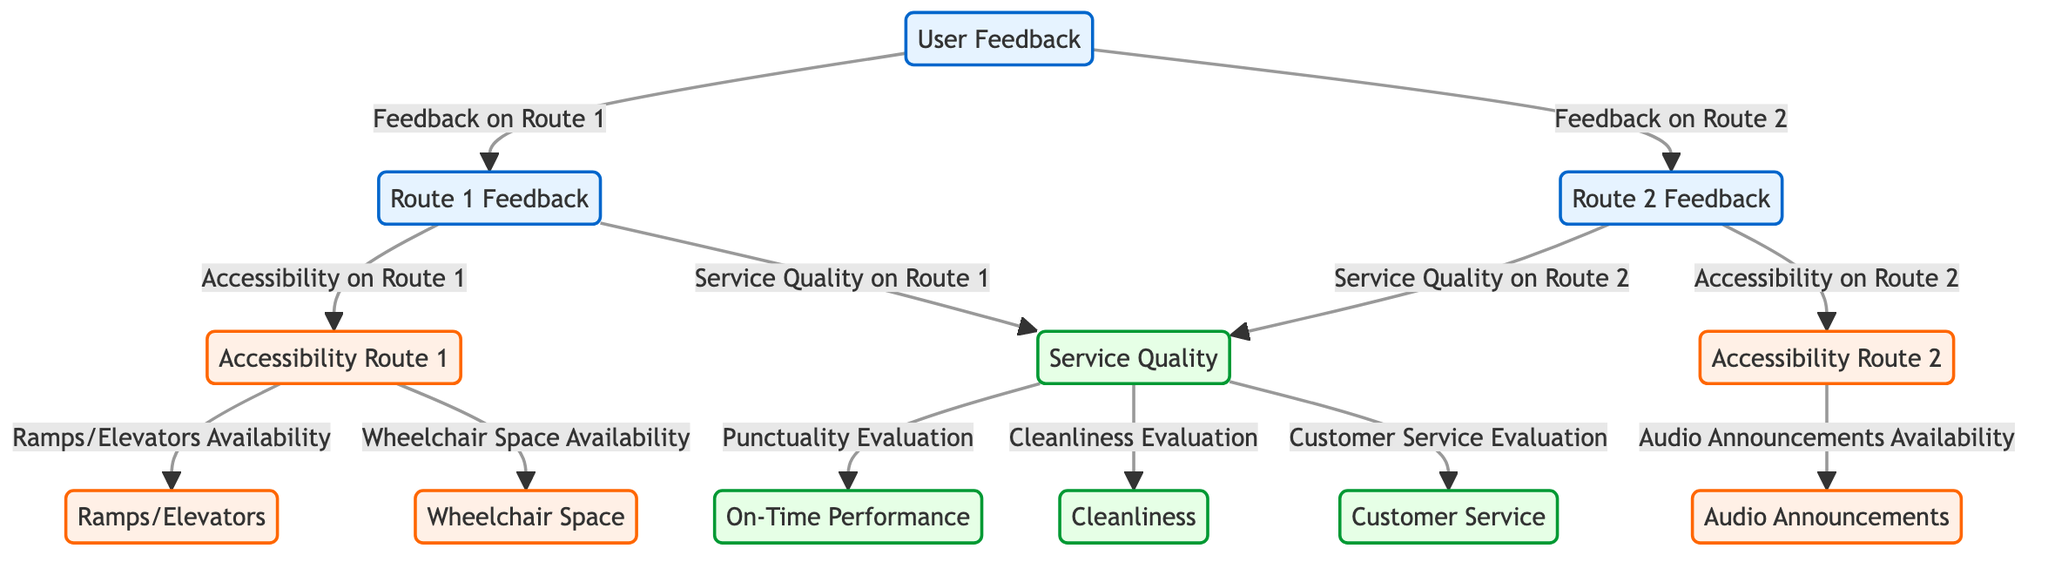What are the two routes represented in the user feedback? The diagram shows feedback specifically for Route 1 and Route 2, which can be identified at the top nodes branching from the User Feedback node.
Answer: Route 1, Route 2 How many types of accessibility features are linked to Route 1? The diagram indicates that Route 1 has two specific accessibility features: Ramps/Elevators Availability and Wheelchair Space Availability. Both are connected directly to the Accessibility Node for Route 1.
Answer: 2 What is the connection between service quality on Route 1 and punctuality evaluation? The diagram shows that Service Quality on Route 1 leads to Punctuality Evaluation, which indicates that these two nodes are directly linked. To find this connection, we can trace the path from Route 1 Feedback to Service Quality and then to On-Time Performance (Punctuality Evaluation).
Answer: Directly linked Which accessibility feature is associated with Route 2? In the diagram, Audio Announcements Availability is specifically linked to Accessibility on Route 2, showing it's a unique feature available for that route. This can be confirmed by looking at the paths stemming from Route 2 Feedback.
Answer: Audio Announcements What is the total number of accessibility nodes in the diagram? The diagram lists a total of four distinct accessibility features that users can provide feedback on, which are: Ramps/Elevators Availability, Wheelchair Space Availability, Audio Announcements Availability, and Accessibility Route 1 and 2 nodes.
Answer: 4 Which aspect of service quality has the same level of connection as cleanliness? The diagram shows that Customer Service Evaluation is another aspect of Service Quality, just like Cleanliness Evaluation, as both are directly connected beneath the Service Quality node. They have the same type of relationship in that they both assess the overall service quality alongside punctuality.
Answer: Customer Service Evaluation What type of diagram is being represented here? This is a Textbook Diagram, characterized by its use of flowcharts to illustrate the relationships between concepts, in this case, user feedback concerning accessibility features and service quality assessment.
Answer: Textbook Diagram How does user feedback relate to Route feedback? The diagram illustrates a direct relationship where User Feedback connects to both Route 1 Feedback and Route 2 Feedback, which signifies that all feedback is categorized based on these specific routes.
Answer: Direct relationship 